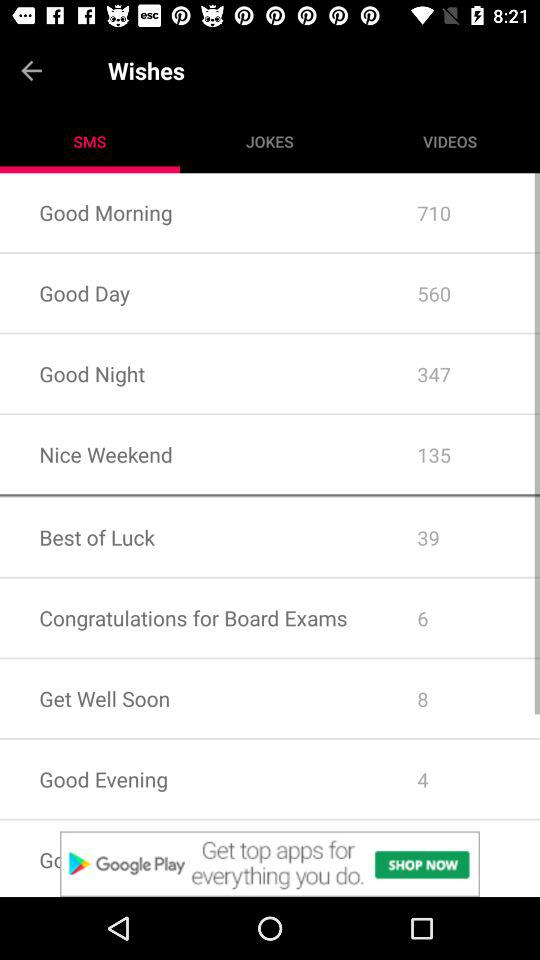How many messages are there for "Good Night"? There are total 347 messages. 